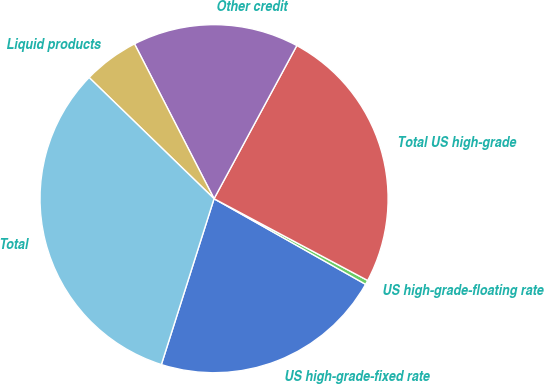<chart> <loc_0><loc_0><loc_500><loc_500><pie_chart><fcel>US high-grade-fixed rate<fcel>US high-grade-floating rate<fcel>Total US high-grade<fcel>Other credit<fcel>Liquid products<fcel>Total<nl><fcel>21.71%<fcel>0.4%<fcel>24.9%<fcel>15.44%<fcel>5.19%<fcel>32.36%<nl></chart> 